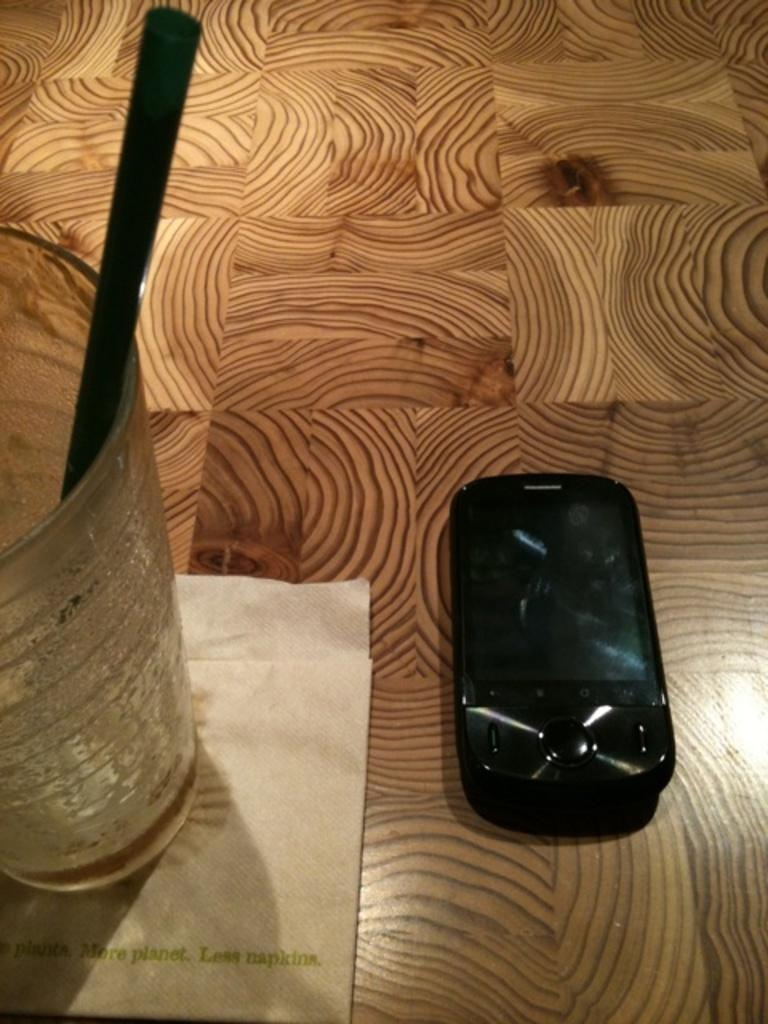Provide a one-sentence caption for the provided image. A drink sits on a napkin reading more planet, less napkins. 